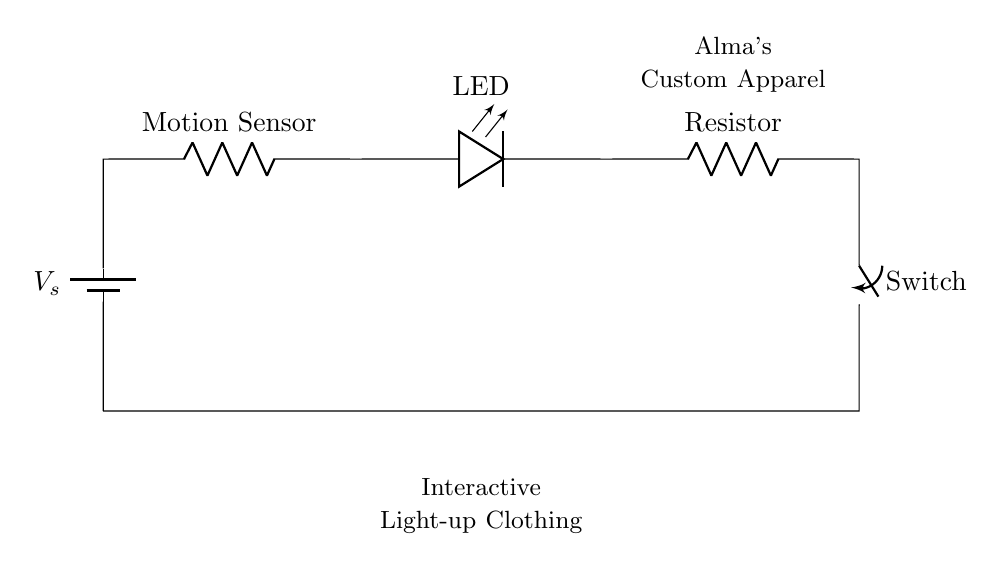What component is used as the power source? The power source in the circuit is represented by a battery symbol, indicating it provides electrical energy.
Answer: Battery What does the motion sensor do in this circuit? The motion sensor detects movement and completes the circuit when motion is detected, allowing current to flow to the LED.
Answer: Detects motion How many resistors are present in the circuit? There is one resistor indicated in the circuit, which helps limit the current flowing to the LED.
Answer: One What type of circuit is depicted in the diagram? The circuit is a series circuit, as all components are connected in a single path. If one component fails, the entire circuit stops functioning.
Answer: Series How does the switch affect the circuit? The switch can open or close the circuit. When closed, current flows, and the LED lights up. When open, current stops, and the LED turns off.
Answer: Controls current What happens to the LED when the motion sensor detects movement? When the motion sensor detects movement, it allows current to flow, which lights up the LED, making the clothing interactive.
Answer: LED lights up What is the purpose of the resistor in this circuit? The resistor limits the current flowing to the LED to prevent it from burning out due to excessive current.
Answer: Limits current 